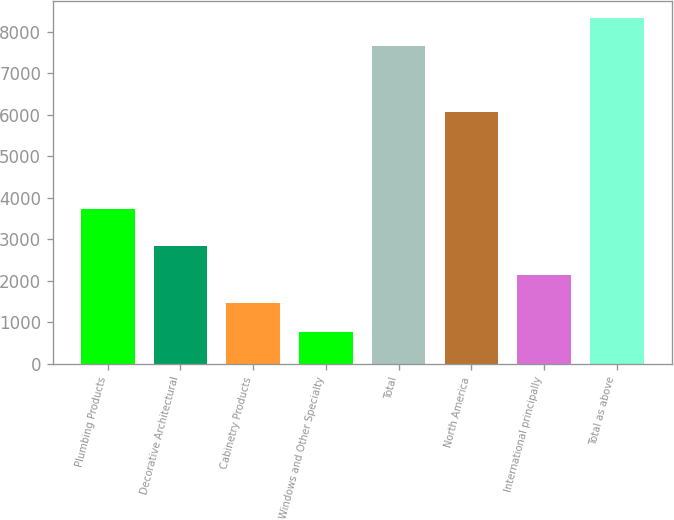Convert chart to OTSL. <chart><loc_0><loc_0><loc_500><loc_500><bar_chart><fcel>Plumbing Products<fcel>Decorative Architectural<fcel>Cabinetry Products<fcel>Windows and Other Specialty<fcel>Total<fcel>North America<fcel>International principally<fcel>Total as above<nl><fcel>3732<fcel>2831.6<fcel>1457.2<fcel>770<fcel>7642<fcel>6067<fcel>2144.4<fcel>8329.2<nl></chart> 